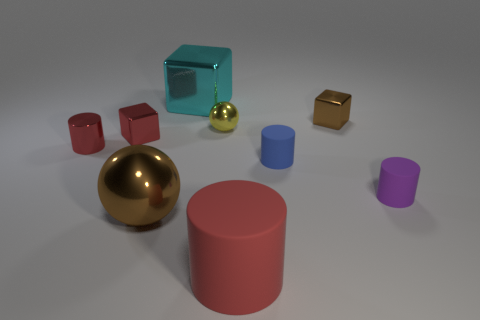What color is the metallic ball behind the tiny cube in front of the metallic block to the right of the red rubber cylinder?
Make the answer very short. Yellow. Are there any other things that are the same color as the small metal cylinder?
Keep it short and to the point. Yes. Do the purple thing and the brown cube have the same size?
Give a very brief answer. Yes. How many things are matte cylinders in front of the large brown sphere or small purple matte cylinders that are right of the tiny yellow shiny object?
Offer a very short reply. 2. What material is the red thing that is right of the tiny metal block to the left of the red matte cylinder?
Offer a terse response. Rubber. What number of other things are the same material as the small purple thing?
Your answer should be very brief. 2. Do the cyan object and the small brown thing have the same shape?
Offer a very short reply. Yes. What is the size of the metal thing behind the small brown thing?
Provide a short and direct response. Large. Does the blue object have the same size as the cyan metal object left of the large matte cylinder?
Offer a terse response. No. Are there fewer blue rubber cylinders that are to the left of the small yellow shiny object than metal objects?
Give a very brief answer. Yes. 